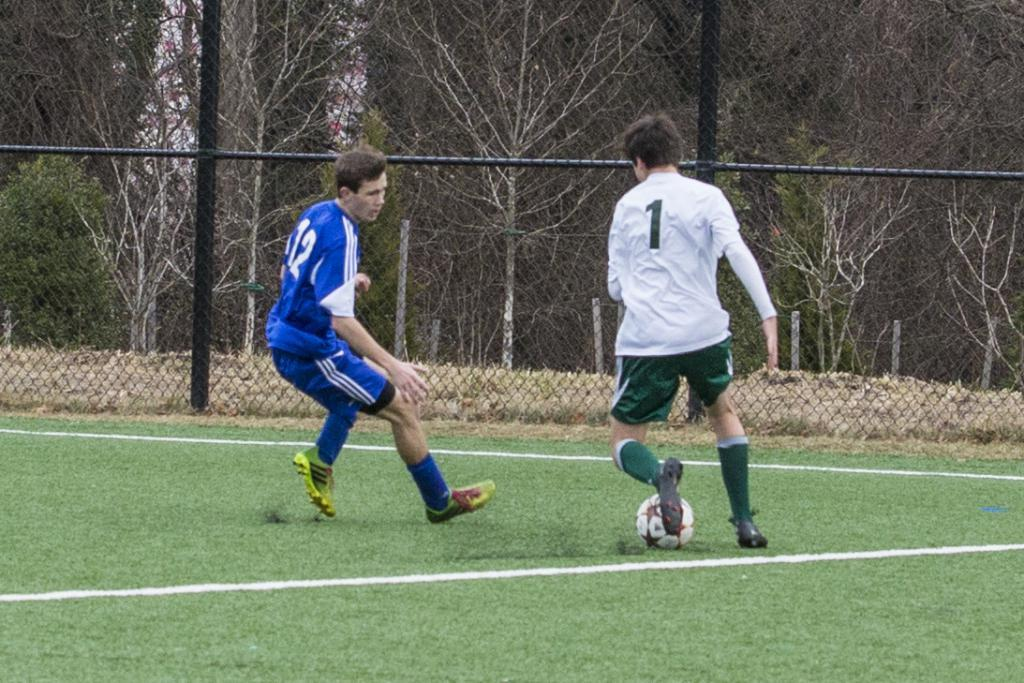Provide a one-sentence caption for the provided image. A man with a white soccer shirt with a 1 on the back kicks a soccer ball. 